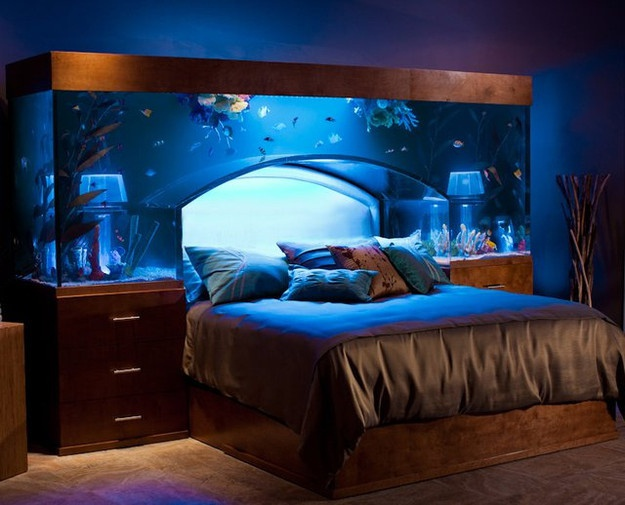Describe the objects in this image and their specific colors. I can see a bed in navy, black, maroon, and lightblue tones in this image. 